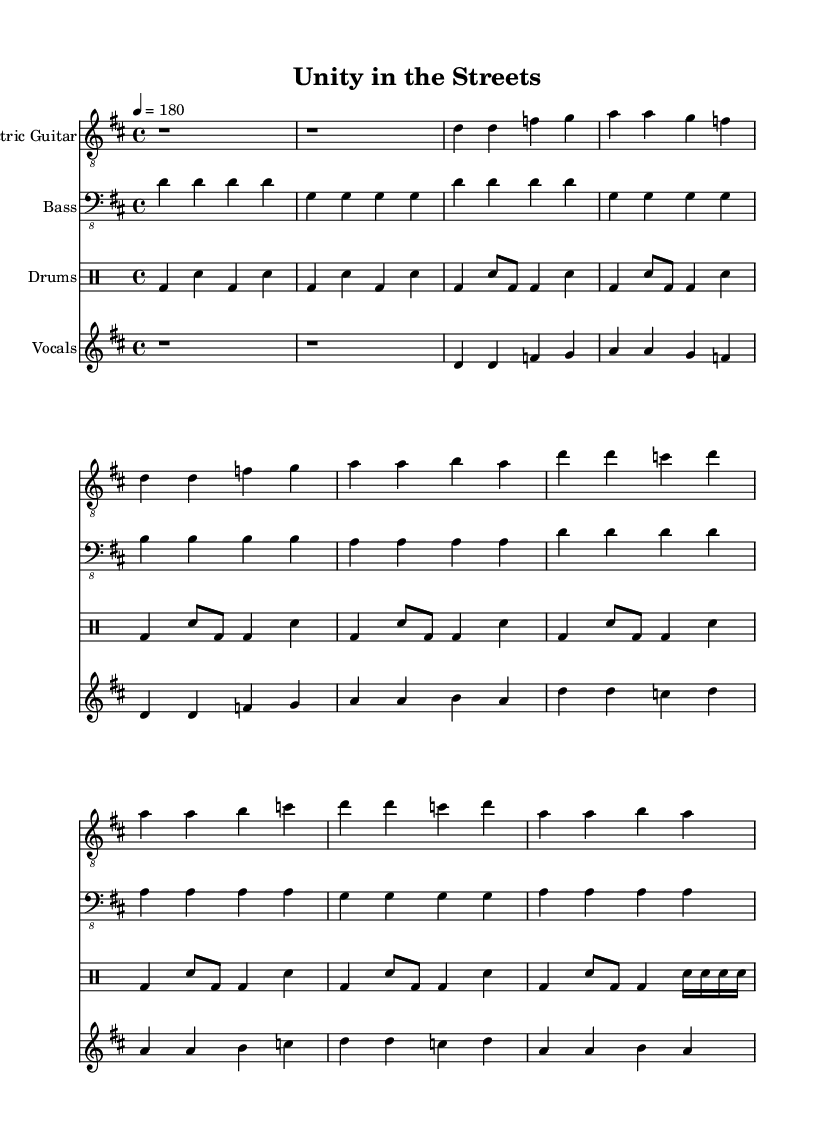What is the key signature of this music? The key signature is D major, which has two sharps (F# and C#).
Answer: D major What is the time signature? The time signature is 4/4, indicating four beats in a measure.
Answer: 4/4 What is the tempo marking for this piece? The tempo marking indicates that the music should be played at a speed of 180 beats per minute.
Answer: 180 How many measures are in the verse section? The verse section consists of four measures based on the notation provided for the verse.
Answer: 4 In which section does the lyric “Unity in diversity, our strength, our choice” occur? This lyric occurs in the chorus section, where the overall theme of unity is emphasized.
Answer: Chorus What is the rhythmic pattern for the drums in the intro? The rhythmic pattern consists of bass drum and snare hits in a structured pattern of four beats.
Answer: bass drum and snare What is the overall theme of the lyrics? The overall theme revolves around unity and diversity within urban communities, celebrating togetherness.
Answer: Unity and diversity 